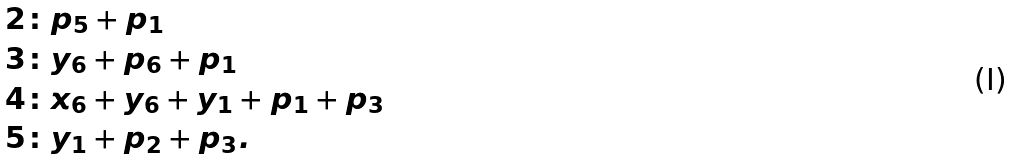<formula> <loc_0><loc_0><loc_500><loc_500>2 \colon & p _ { 5 } + p _ { 1 } \\ 3 \colon & y _ { 6 } + p _ { 6 } + p _ { 1 } \\ 4 \colon & x _ { 6 } + y _ { 6 } + y _ { 1 } + p _ { 1 } + p _ { 3 } \\ 5 \colon & y _ { 1 } + p _ { 2 } + p _ { 3 } .</formula> 